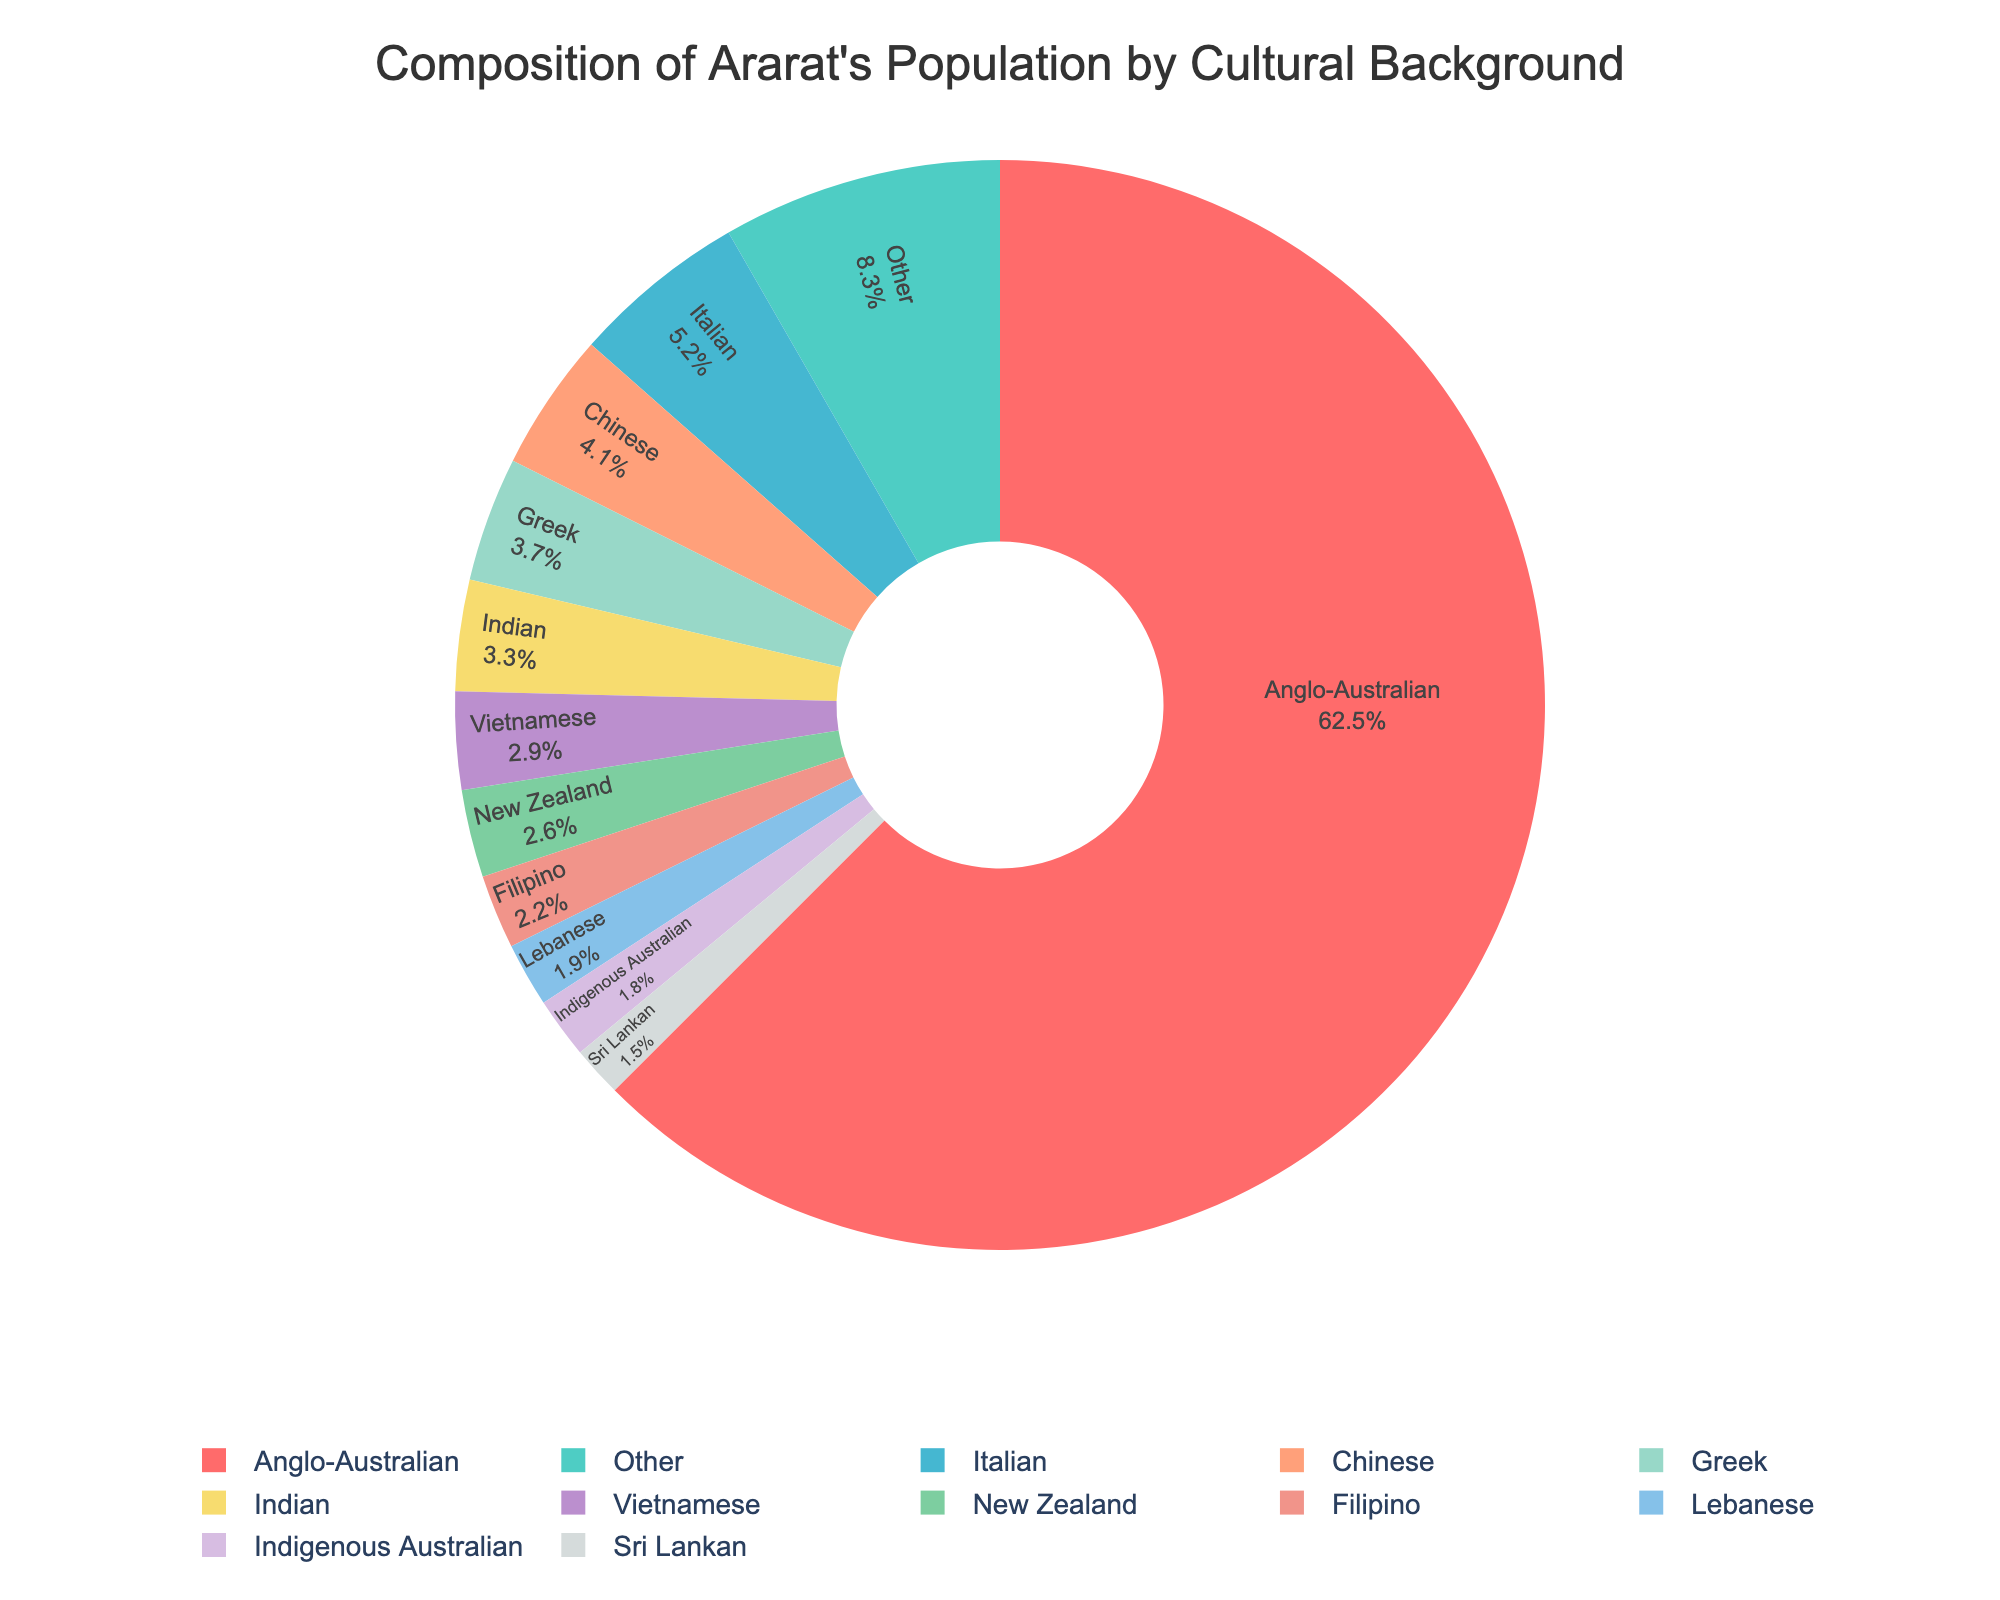What's the percentage of Anglo-Australians and Indigenous Australians combined? The pie chart shows that Anglo-Australians make up 62.5% and Indigenous Australians make up 1.8%. Adding these two percentages together gives 62.5 + 1.8 = 64.3%.
Answer: 64.3% Which cultural background has a higher percentage, Greek or Chinese? The pie chart indicates that Greeks make up 3.7% of the population, while the Chinese make up 4.1%. Since 4.1% is greater than 3.7%, the Chinese population is higher.
Answer: Chinese Is the percentage of Vietnamese people greater than the combined percentage of Sri Lankan and Lebanese people? The Vietnamese population is 2.9%. The Sri Lankan population is 1.5% and the Lebanese population is 1.9%. Adding the Sri Lankan and Lebanese percentages together gives 1.5 + 1.9 = 3.4%, which is greater than 2.9%.
Answer: No What is the percentage difference between the Italian and the Filipino populations? The pie chart shows that Italians make up 5.2% of the population, while Filipinos make up 2.2%. The difference between these percentages is 5.2 - 2.2 = 3.0%.
Answer: 3.0% Identify the cultural background that occupies the smallest segment in the pie chart. The pie chart shows various percentages, and the smallest percentage listed is 1.5% for Sri Lankan. Therefore, Sri Lankan occupies the smallest segment.
Answer: Sri Lankan Which cultural background is represented by a red segment in the pie chart? According to the code, the first color in the custom palette is red, and the largest segment (first in descending order) is Anglo-Australian with 62.5%. Hence, the red segment represents Anglo-Australian.
Answer: Anglo-Australian What is the percentage of the 'Other' category, and how does it compare to the Indian population? The 'Other' category makes up 8.3% of the population, while the Indian population is 3.3%. Comparing the two percentages, 8.3% is greater than 3.3%.
Answer: 8.3%, greater Which three cultural backgrounds have the closest population percentages to each other? Reviewing the percentages, Greek is 3.7%, Chinese is 4.1%, and Indian is 3.3%. These three percentages are the closest to each other because the differences between them are small (4.1 - 3.7 = 0.4, and 3.7 - 3.3 = 0.4).
Answer: Greek, Chinese, Indian 